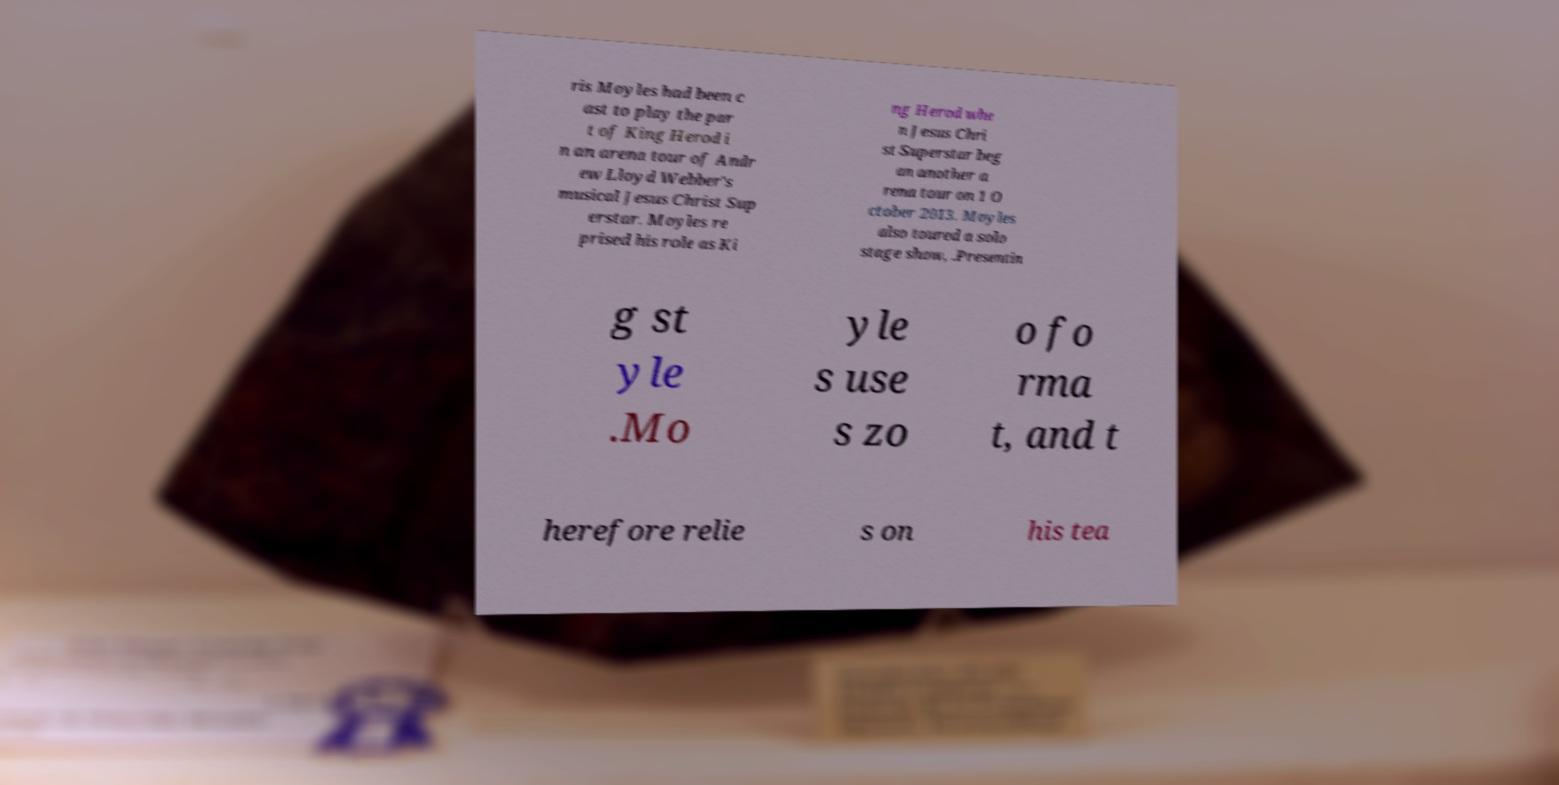Please identify and transcribe the text found in this image. ris Moyles had been c ast to play the par t of King Herod i n an arena tour of Andr ew Lloyd Webber's musical Jesus Christ Sup erstar. Moyles re prised his role as Ki ng Herod whe n Jesus Chri st Superstar beg an another a rena tour on 1 O ctober 2013. Moyles also toured a solo stage show, .Presentin g st yle .Mo yle s use s zo o fo rma t, and t herefore relie s on his tea 